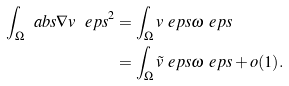<formula> <loc_0><loc_0><loc_500><loc_500>\int _ { \Omega } \ a b s { \nabla v ^ { \ } e p s } ^ { 2 } & = \int _ { \Omega } v ^ { \ } e p s \omega ^ { \ } e p s \\ & = \int _ { \Omega } \tilde { v } ^ { \ } e p s \omega ^ { \ } e p s + o ( 1 ) .</formula> 